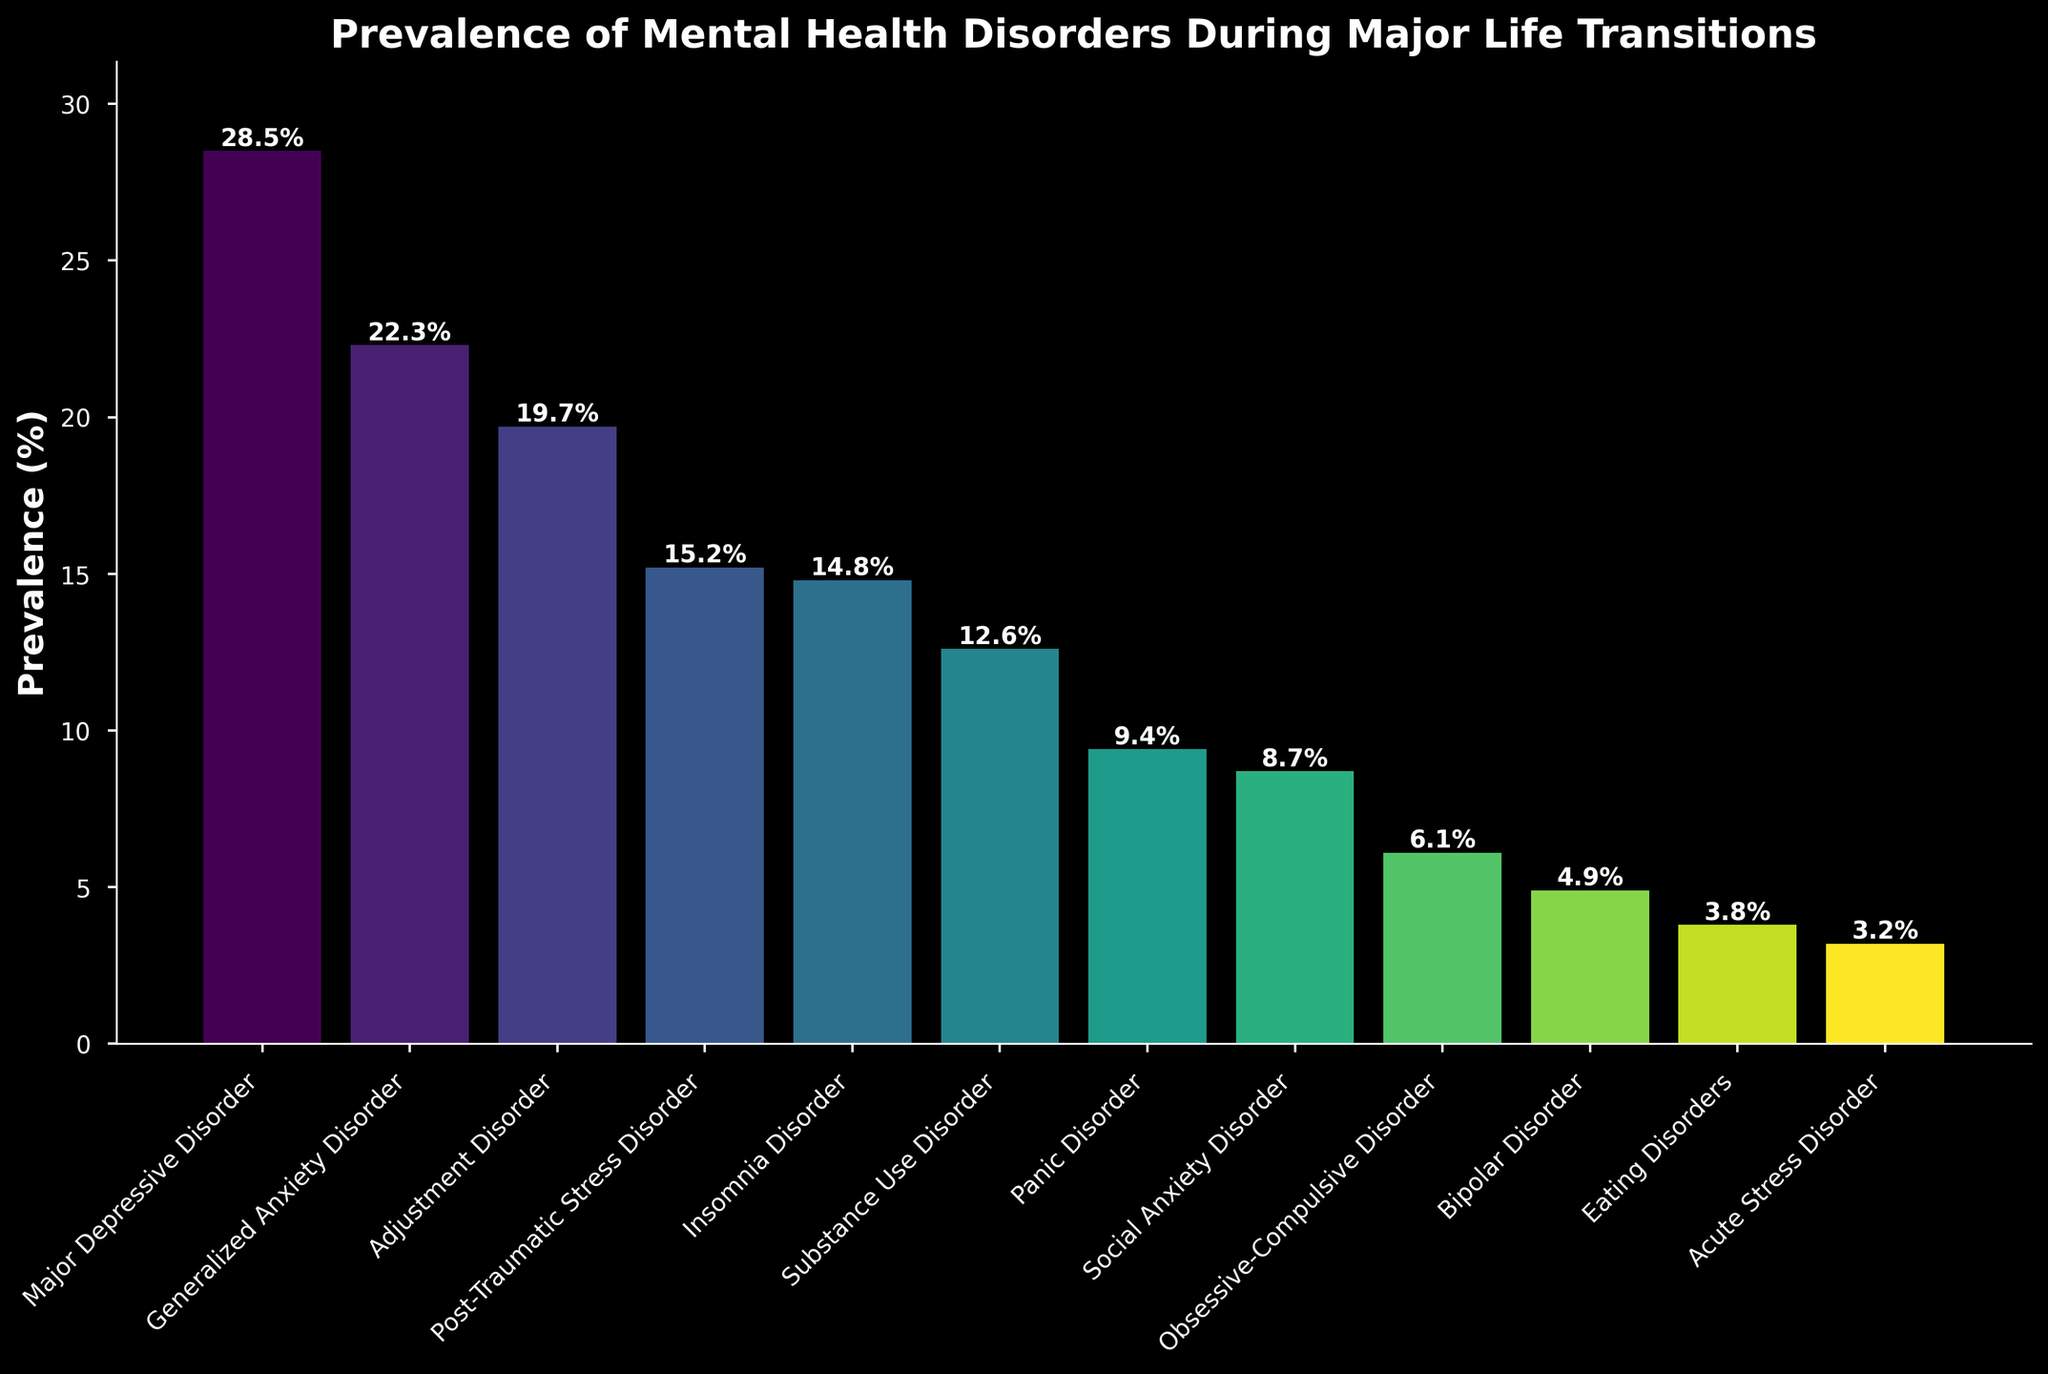What is the prevalence of Generalized Anxiety Disorder? Look at the height of the bar corresponding to Generalized Anxiety Disorder, which is labeled with the prevalence percentage.
Answer: 22.3% What is the difference in prevalence between Major Depressive Disorder and Bipolar Disorder? Find the heights of the bars for Major Depressive Disorder (28.5%) and Bipolar Disorder (4.9%), then subtract the latter from the former. 28.5 - 4.9 = 23.6
Answer: 23.6% Which disorder has the lowest prevalence? Identify the bar with the smallest height. The label for this bar shows the disorder with the lowest prevalence, Acute Stress Disorder.
Answer: Acute Stress Disorder How much higher is the prevalence of Insomnia Disorder compared to Panic Disorder? Find the heights of the bars for Insomnia Disorder (14.8%) and Panic Disorder (9.4%). Subtract the latter from the former. 14.8 - 9.4 = 5.4
Answer: 5.4% Which two disorders have the closest prevalence rates? Compare the heights of all the bars to find two bars that are visually closest in height. The bars for Insomnia Disorder (14.8%) and Post-Traumatic Stress Disorder (15.2%) are closest.
Answer: Insomnia Disorder and Post-Traumatic Stress Disorder What is the combined prevalence of Adjustment Disorder and Substance Use Disorder? Add the heights of the bars for Adjustment Disorder (19.7%) and Substance Use Disorder (12.6%). 19.7 + 12.6 = 32.3
Answer: 32.3% Which disorder has a prevalence approximately half of Generalized Anxiety Disorder? Find half the prevalence of Generalized Anxiety Disorder (22.3%). Half of 22.3 is approximately 11.15. Identify the bar closest to this value, which is Substance Use Disorder (12.6%).
Answer: Substance Use Disorder Compare the prevalence rate of Social Anxiety Disorder with Eating Disorders. Which is higher and by how much? Compare the heights of the bars for Social Anxiety Disorder (8.7%) and Eating Disorders (3.8%), then find the difference. 8.7 - 3.8 = 4.9
Answer: Social Anxiety Disorder, 4.9% What is the total prevalence of disorders with a rate above 20%? Identify the bars with prevalence rates above 20%: Major Depressive Disorder (28.5%) and Generalized Anxiety Disorder (22.3%), then sum these values. 28.5 + 22.3 = 50.8
Answer: 50.8% Which disorder has the third highest prevalence? Visually inspect the heights of the bars to identify the three tallest. The third tallest bar corresponds to Adjustment Disorder, with a prevalence of 19.7%.
Answer: Adjustment Disorder 